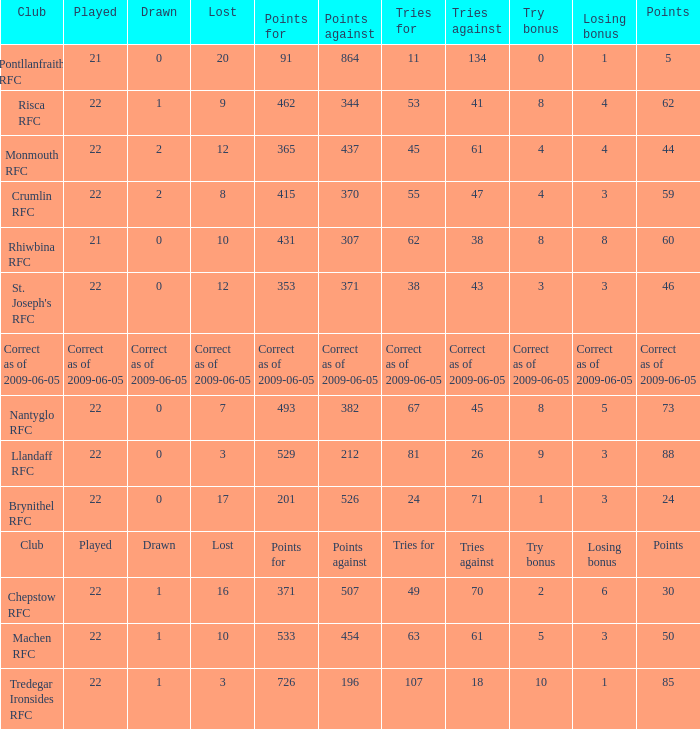If the Played was played, what is the lost? Lost. 